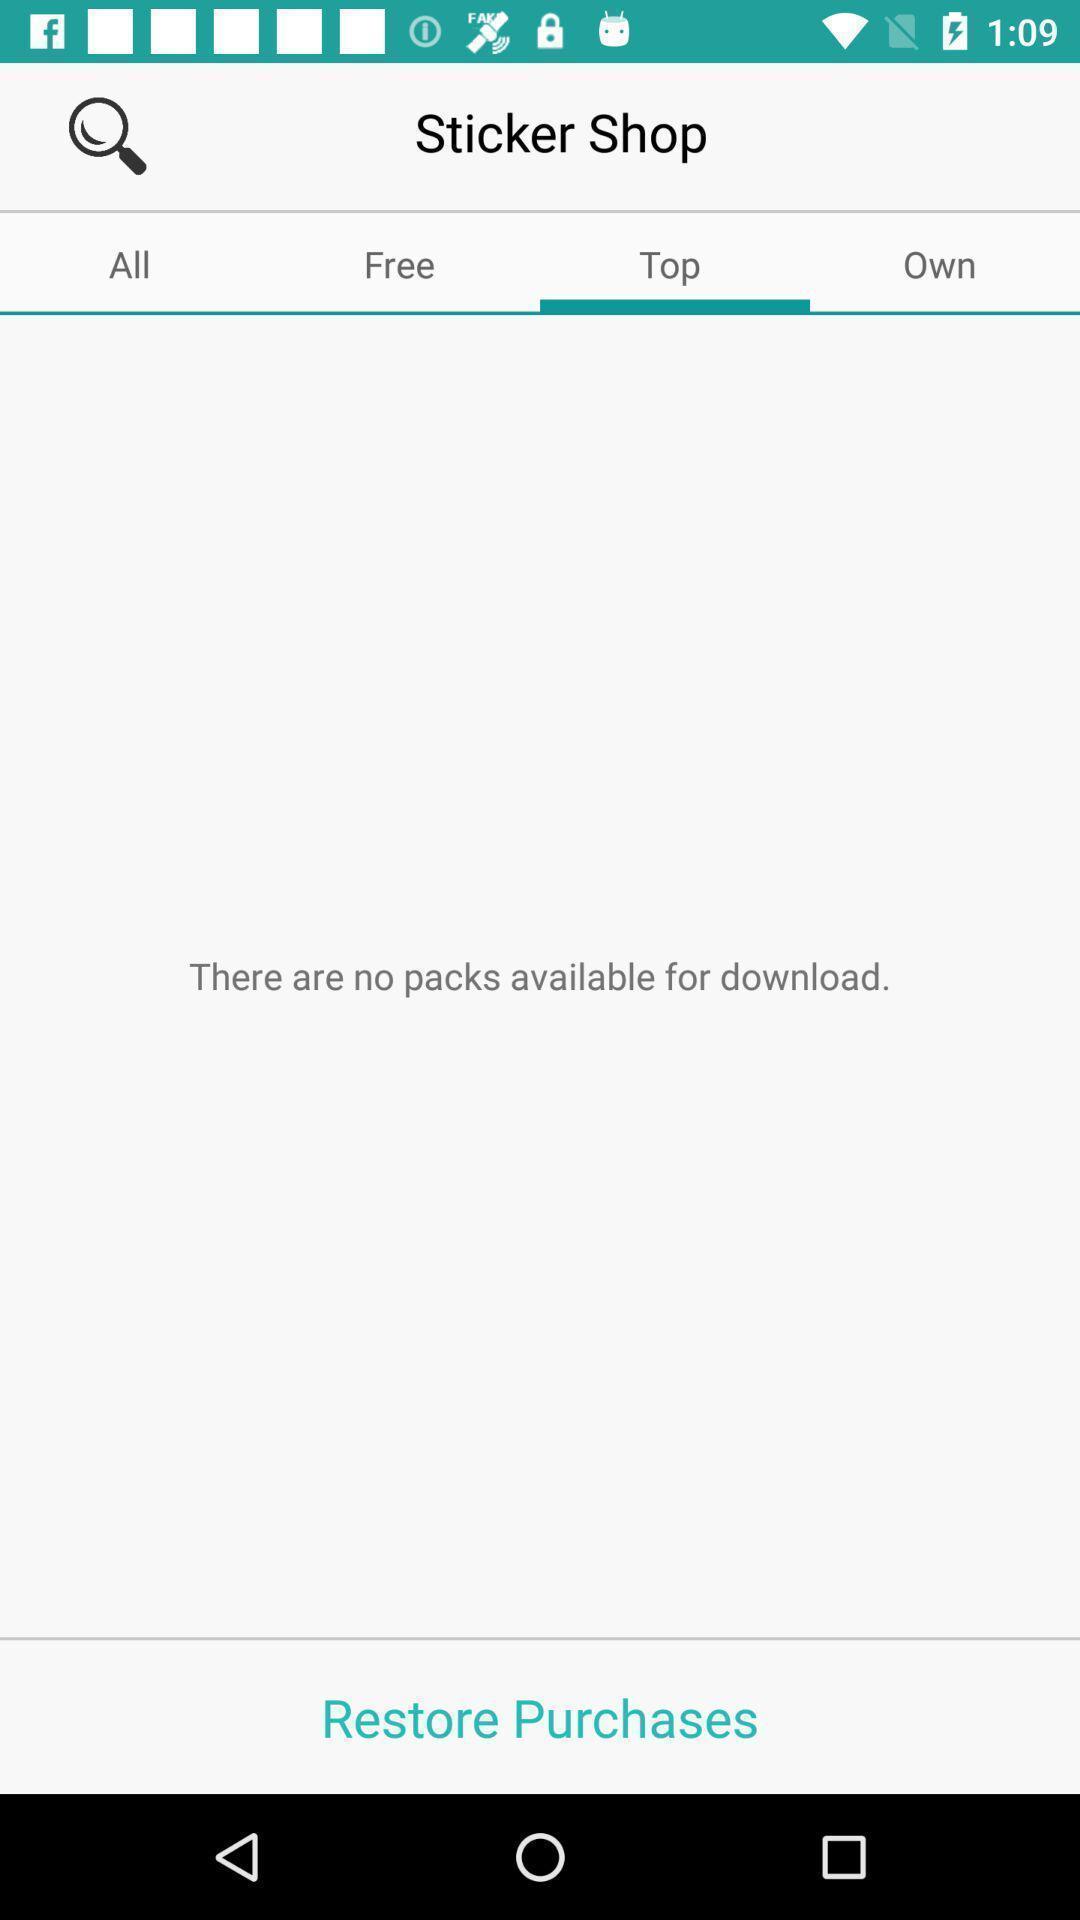Tell me about the visual elements in this screen capture. Page showing option of sticker. 